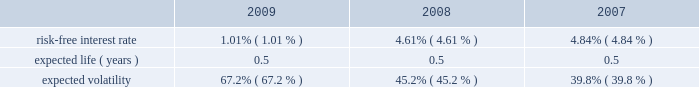Abiomed , inc .
And subsidiaries notes to consolidated financial statements 2014 ( continued ) note 12 .
Stock award plans and stock based compensation ( continued ) compensation expense recognized related to the company 2019s espp was approximately $ 0.1 million for each of the years ended march 31 , 2009 , 2008 and 2007 respectively .
The fair value of shares issued under the employee stock purchase plan was estimated on the commencement date of each offering period using the black-scholes option-pricing model with the following assumptions: .
Note 13 .
Capital stock in august 2008 , the company issued 2419932 shares of its common stock at a price of $ 17.3788 in a public offering , which resulted in net proceeds to the company of approximately $ 42.0 million , after deducting offering expenses .
In march 2007 , the company issued 5000000 shares of common stock in a public offering , and in april 2007 , an additional 80068 shares of common stock were issued in connection with the offering upon the partial exercise of the underwriters 2019 over-allotment option .
The company has authorized 1000000 shares of class b preferred stock , $ 0.01 par value , of which the board of directors can set the designation , rights and privileges .
No shares of class b preferred stock have been issued or are outstanding .
Note 14 .
Income taxes deferred tax assets and liabilities are recognized for the estimated future tax consequences attributable to tax benefit carryforwards and to differences between the financial statement amounts of assets and liabilities and their respective tax basis .
Deferred tax assets and liabilities are measured using enacted tax rates .
A valuation reserve is established if it is more likely than not that all or a portion of the deferred tax asset will not be realized .
The tax benefit associated with the stock option compensation deductions will be credited to equity when realized .
At march 31 , 2009 , the company had federal and state net operating loss carryforwards , or nols , of approximately $ 145.1 million and $ 97.1 million , respectively , which begin to expire in fiscal 2010 .
Additionally , at march 31 , 2009 , the company had federal and state research and development credit carryforwards of approximately $ 8.1 million and $ 4.2 million , respectively , which begin to expire in fiscal 2010 .
The company acquired impella , a german-based company , in may 2005 .
Impella had pre-acquisition net operating losses of approximately $ 18.2 million at the time of acquisition ( which is denominated in euros and is subject to foreign exchange remeasurement at each balance sheet date presented ) , and has since incurred net operating losses in each fiscal year since the acquisition .
During fiscal 2008 , the company determined that approximately $ 1.2 million of pre-acquisition operating losses could not be utilized .
The utilization of pre-acquisition net operating losses of impella in future periods is subject to certain statutory approvals and business requirements .
Due to uncertainties surrounding the company 2019s ability to generate future taxable income to realize these assets , a full valuation allowance has been established to offset the company 2019s net deferred tax assets and liabilities .
Additionally , the future utilization of the company 2019s nol and research and development credit carry forwards to offset future taxable income may be subject to a substantial annual limitation under section 382 of the internal revenue code due to ownership changes that have occurred previously or that could occur in the future .
Ownership changes , as defined in section 382 of the internal revenue code , can limit the amount of net operating loss carry forwards and research and development credit carry forwards that a company can use each year to offset future taxable income and taxes payable .
The company believes that all of its federal and state nol 2019s will be available for carryforward to future tax periods , subject to the statutory maximum carryforward limitation of any annual nol .
Any future potential limitation to all or a portion of the nol or research and development credit carry forwards , before they can be utilized , would reduce the company 2019s gross deferred tax assets .
The company will monitor subsequent ownership changes , which could impose limitations in the future. .
What is the growth rate in risk-free interest rate from 2007 to 2008? 
Computations: ((4.61 - 4.84) / 4.84)
Answer: -0.04752. 